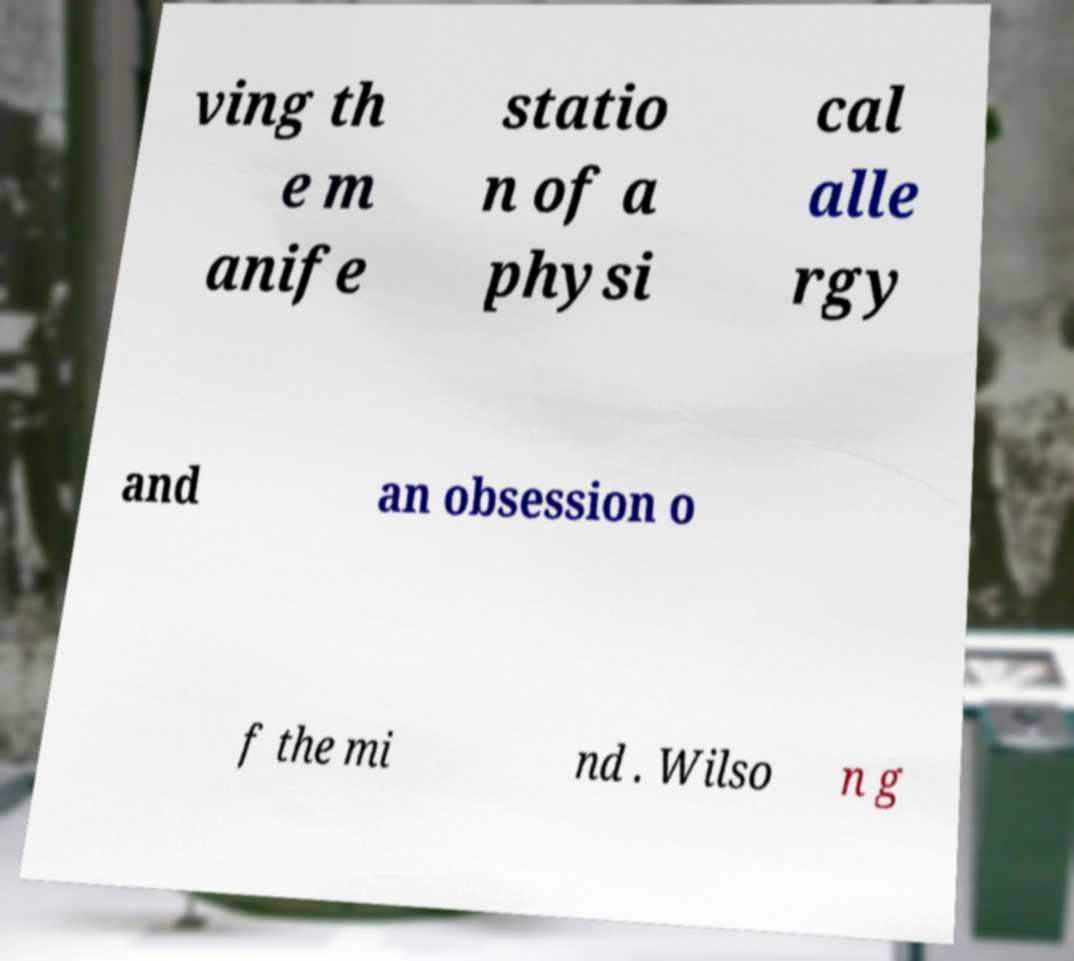Could you assist in decoding the text presented in this image and type it out clearly? ving th e m anife statio n of a physi cal alle rgy and an obsession o f the mi nd . Wilso n g 